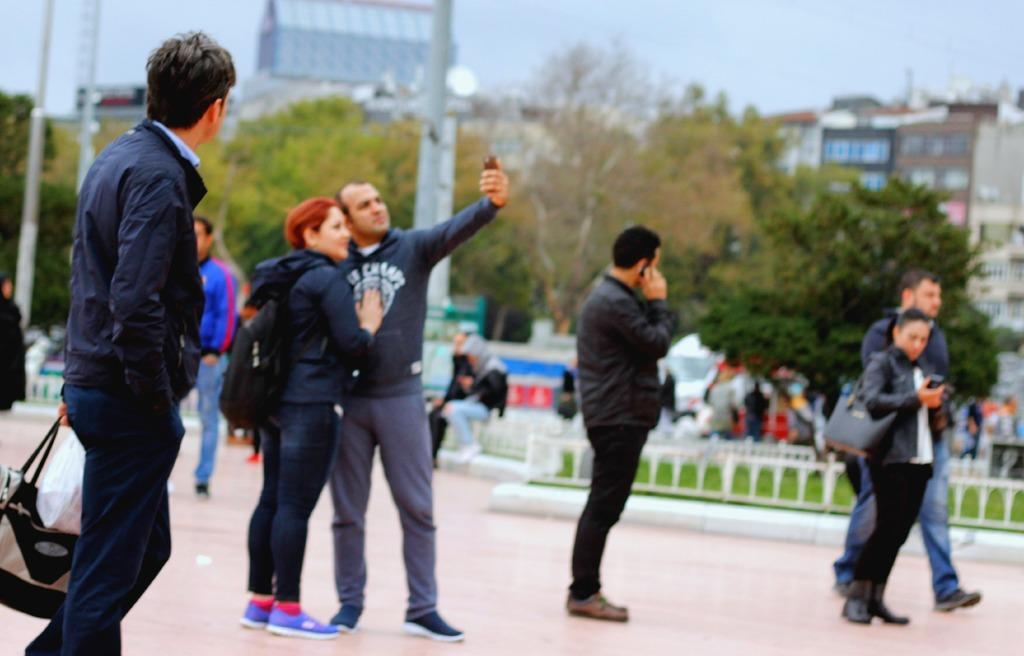Where are the people located in the image? There are people on the right side of the image and on the left side of the image. Can you describe the background of the image? In the background of the image, there are buildings, trees, and poles. How many people can be seen in the image? There are people on both sides of the image and in the background, so it's difficult to give an exact number. What is the quality of the background in the image? The background area of the image is blurred. What type of alarm is ringing in the image? There is no alarm present in the image. Can you tell me what the queen is wearing in the image? There is no queen present in the image. 